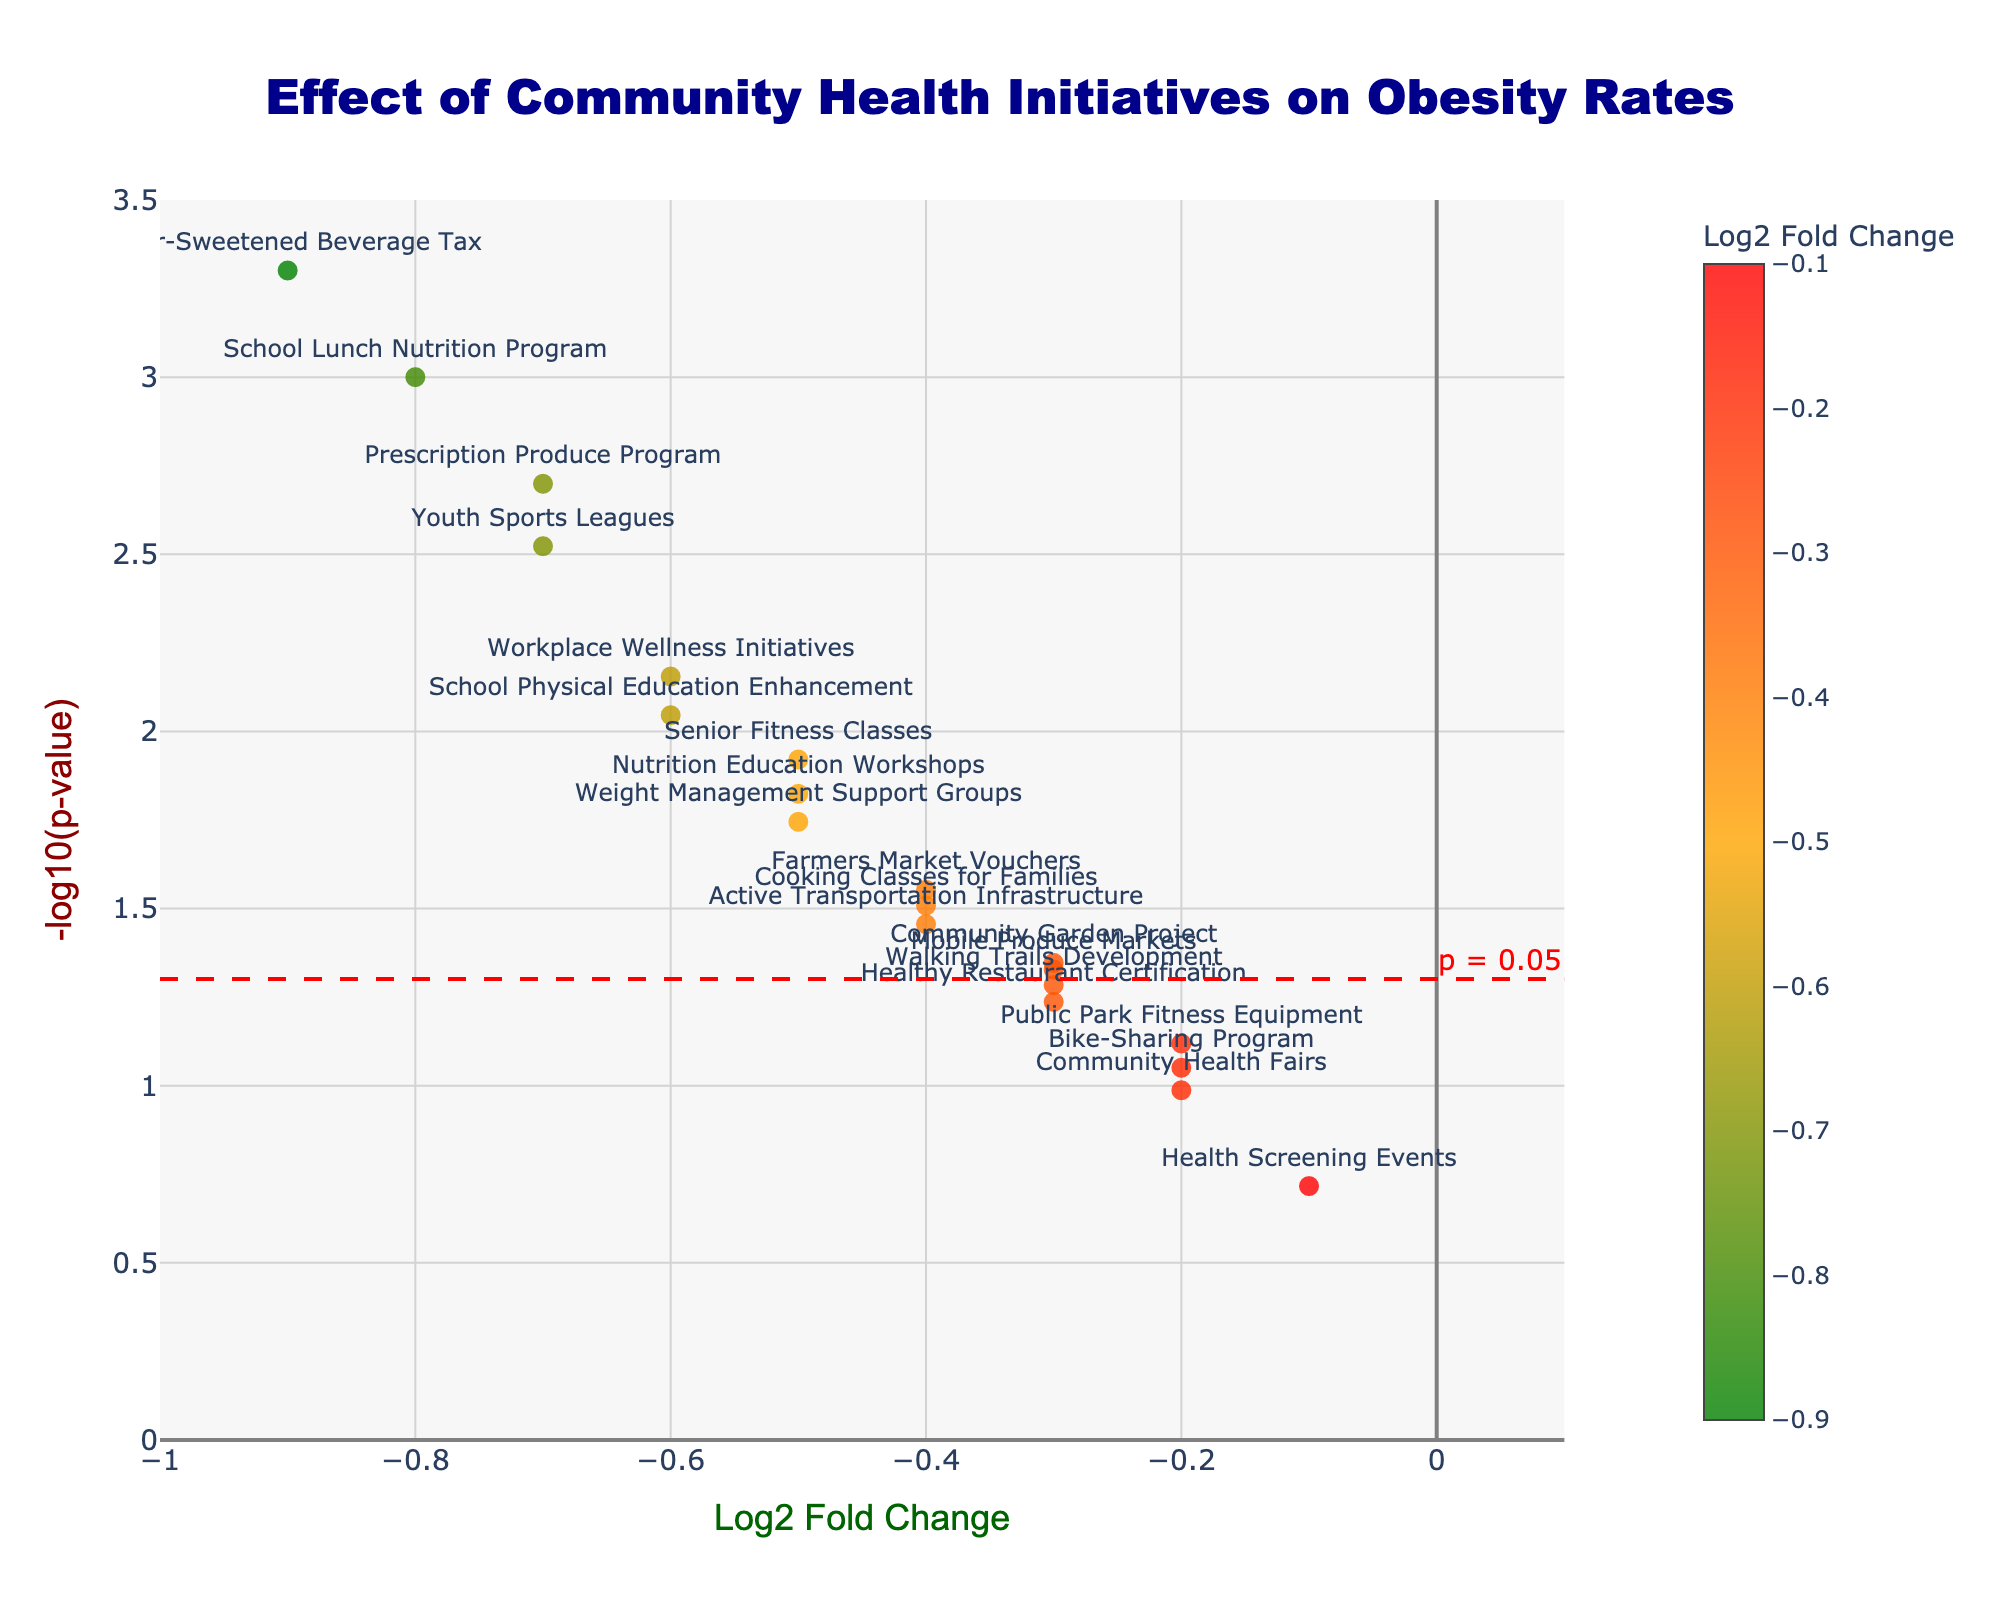What is the title of the figure? The title of the figure is clearly indicated at the top. By looking at the middle top of the figure, you can see the title is "Effect of Community Health Initiatives on Obesity Rates".
Answer: Effect of Community Health Initiatives on Obesity Rates What does the x-axis represent? The label of the x-axis is explicitly written at the bottom of the figure. It reads "Log2 Fold Change", representing the logarithm (base 2) of the fold changes in obesity rates.
Answer: Log2 Fold Change How many initiatives are plotted on the figure? Each marker in the plot represents one initiative. By counting these markers, you can see there are 19 initiatives plotted on the figure.
Answer: 19 Which initiative has the smallest p-value and what is its -log10(p-value)? By identifying the marker with the highest value on the y-axis (since -log10(p-value)), it corresponds to the "Sugar-Sweetened Beverage Tax" initiative. By examining the plot, its -log10(p-value) is highest, translating to the lowest p-value. For the exact value, it corresponds to October around 3.3010
Answer: Sugar-Sweetened Beverage Tax, 3.3010 What does a negative Log2 Fold Change indicate about the initiatives' effect? In the context of this plot, a negative Log2 Fold Change indicates a reduction in obesity rates as a result of the health initiative.
Answer: Reduction in obesity rates Which initiatives have the least statistically significant results (p-values just above 0.05)? Initiatives below the red reference line at -log10(0.05) are the least statistically significant. These are "Health Screening Events", "Community Health Fairs", and "Healthy Restaurant Certification".
Answer: Health Screening Events, Community Health Fairs, Healthy Restaurant Certification Which initiatives fall closest to the significance threshold line (p = 0.05)? By checking the data points near the red dashed line indicating the p = 0.05 threshold, we find "Bike-Sharing Program" and "Walking Trails Development" as closest to this line.
Answer: Bike-Sharing Program, Walking Trails Development How do the effects of "School Physical Education Enhancement" and "Youth Sports Leagues" compare in terms of Log2 Fold Change, and which has a more significant p-value? Comparing the two, "School Physical Education Enhancement" has a Log2 Fold Change of -0.6 and "Youth Sports Leagues" has -0.7. "Youth Sports Leagues" has a slightly more significant p-value (higher on the y-axis).
Answer: Youth Sports Leagues has a more significant p-value and a slightly greater reduction What is the impact of the "Workplace Wellness Initiatives" on obesity rates based on Log2 Fold Change and statistical significance? "Workplace Wellness Initiatives" has a Log2 Fold Change of -0.6, indicating a reduction in obesity rates, and its p-value is below the 0.05 threshold, indicating it is statistically significant.
Answer: Reduction, statistically significant Which initiatives show a statistically significant effect (p-value < 0.05) and also have a Log2 Fold Change of -0.7 or lower? By looking at the initiatives with markers above the significance threshold line and at the left of -0.7 on the x-axis, "Youth Sports Leagues" and "Prescription Produce Program" meet the criteria.
Answer: Youth Sports Leagues, Prescription Produce Program 